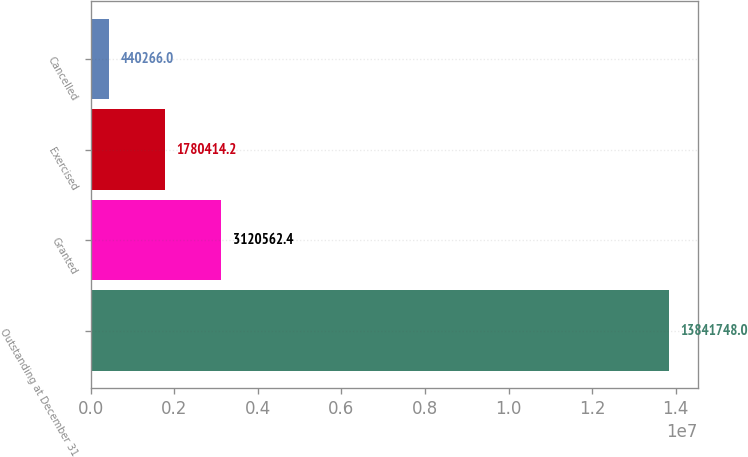<chart> <loc_0><loc_0><loc_500><loc_500><bar_chart><fcel>Outstanding at December 31<fcel>Granted<fcel>Exercised<fcel>Cancelled<nl><fcel>1.38417e+07<fcel>3.12056e+06<fcel>1.78041e+06<fcel>440266<nl></chart> 